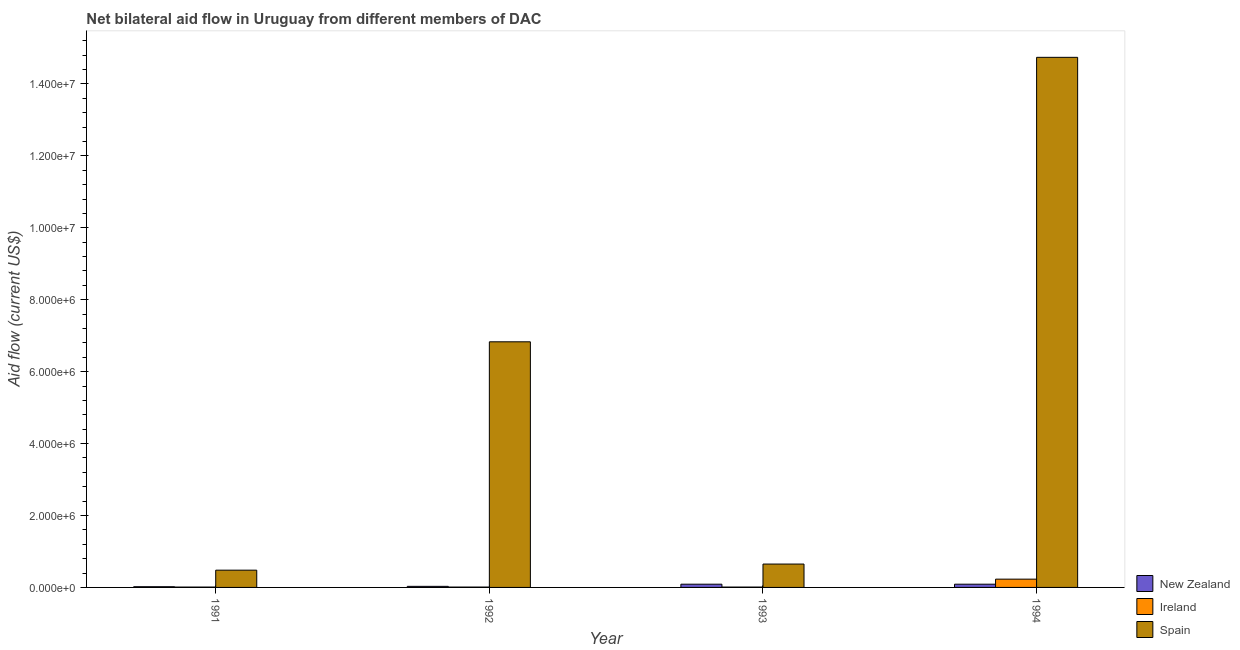How many different coloured bars are there?
Offer a terse response. 3. What is the amount of aid provided by spain in 1993?
Give a very brief answer. 6.50e+05. Across all years, what is the maximum amount of aid provided by new zealand?
Offer a terse response. 9.00e+04. Across all years, what is the minimum amount of aid provided by new zealand?
Provide a short and direct response. 2.00e+04. In which year was the amount of aid provided by spain minimum?
Offer a very short reply. 1991. What is the total amount of aid provided by spain in the graph?
Your response must be concise. 2.27e+07. What is the difference between the amount of aid provided by ireland in 1991 and that in 1994?
Your answer should be very brief. -2.20e+05. What is the difference between the amount of aid provided by new zealand in 1992 and the amount of aid provided by spain in 1994?
Your answer should be compact. -6.00e+04. What is the average amount of aid provided by new zealand per year?
Offer a very short reply. 5.75e+04. In the year 1992, what is the difference between the amount of aid provided by ireland and amount of aid provided by new zealand?
Offer a very short reply. 0. In how many years, is the amount of aid provided by ireland greater than 1600000 US$?
Your response must be concise. 0. What is the ratio of the amount of aid provided by ireland in 1993 to that in 1994?
Provide a short and direct response. 0.04. Is the amount of aid provided by spain in 1992 less than that in 1994?
Provide a succinct answer. Yes. Is the difference between the amount of aid provided by new zealand in 1993 and 1994 greater than the difference between the amount of aid provided by spain in 1993 and 1994?
Offer a very short reply. No. What is the difference between the highest and the second highest amount of aid provided by new zealand?
Ensure brevity in your answer.  0. What is the difference between the highest and the lowest amount of aid provided by ireland?
Keep it short and to the point. 2.20e+05. What does the 3rd bar from the right in 1994 represents?
Keep it short and to the point. New Zealand. Is it the case that in every year, the sum of the amount of aid provided by new zealand and amount of aid provided by ireland is greater than the amount of aid provided by spain?
Keep it short and to the point. No. Does the graph contain any zero values?
Keep it short and to the point. No. Does the graph contain grids?
Offer a very short reply. No. Where does the legend appear in the graph?
Offer a very short reply. Bottom right. How many legend labels are there?
Offer a terse response. 3. How are the legend labels stacked?
Your answer should be very brief. Vertical. What is the title of the graph?
Provide a short and direct response. Net bilateral aid flow in Uruguay from different members of DAC. Does "Labor Tax" appear as one of the legend labels in the graph?
Your response must be concise. No. What is the label or title of the Y-axis?
Your answer should be compact. Aid flow (current US$). What is the Aid flow (current US$) of Spain in 1991?
Your answer should be very brief. 4.80e+05. What is the Aid flow (current US$) in Spain in 1992?
Your response must be concise. 6.83e+06. What is the Aid flow (current US$) in New Zealand in 1993?
Make the answer very short. 9.00e+04. What is the Aid flow (current US$) in Ireland in 1993?
Keep it short and to the point. 10000. What is the Aid flow (current US$) of Spain in 1993?
Offer a very short reply. 6.50e+05. What is the Aid flow (current US$) in Ireland in 1994?
Offer a very short reply. 2.30e+05. What is the Aid flow (current US$) in Spain in 1994?
Your answer should be compact. 1.47e+07. Across all years, what is the maximum Aid flow (current US$) of Ireland?
Make the answer very short. 2.30e+05. Across all years, what is the maximum Aid flow (current US$) of Spain?
Offer a very short reply. 1.47e+07. Across all years, what is the minimum Aid flow (current US$) of Spain?
Offer a terse response. 4.80e+05. What is the total Aid flow (current US$) in Spain in the graph?
Your answer should be compact. 2.27e+07. What is the difference between the Aid flow (current US$) of Spain in 1991 and that in 1992?
Make the answer very short. -6.35e+06. What is the difference between the Aid flow (current US$) of New Zealand in 1991 and that in 1993?
Ensure brevity in your answer.  -7.00e+04. What is the difference between the Aid flow (current US$) in Spain in 1991 and that in 1994?
Your answer should be compact. -1.43e+07. What is the difference between the Aid flow (current US$) in New Zealand in 1992 and that in 1993?
Your answer should be compact. -6.00e+04. What is the difference between the Aid flow (current US$) of Ireland in 1992 and that in 1993?
Ensure brevity in your answer.  0. What is the difference between the Aid flow (current US$) in Spain in 1992 and that in 1993?
Ensure brevity in your answer.  6.18e+06. What is the difference between the Aid flow (current US$) of New Zealand in 1992 and that in 1994?
Ensure brevity in your answer.  -6.00e+04. What is the difference between the Aid flow (current US$) of Spain in 1992 and that in 1994?
Your answer should be compact. -7.91e+06. What is the difference between the Aid flow (current US$) in Spain in 1993 and that in 1994?
Make the answer very short. -1.41e+07. What is the difference between the Aid flow (current US$) in New Zealand in 1991 and the Aid flow (current US$) in Ireland in 1992?
Your answer should be very brief. 10000. What is the difference between the Aid flow (current US$) of New Zealand in 1991 and the Aid flow (current US$) of Spain in 1992?
Your response must be concise. -6.81e+06. What is the difference between the Aid flow (current US$) in Ireland in 1991 and the Aid flow (current US$) in Spain in 1992?
Keep it short and to the point. -6.82e+06. What is the difference between the Aid flow (current US$) of New Zealand in 1991 and the Aid flow (current US$) of Spain in 1993?
Your response must be concise. -6.30e+05. What is the difference between the Aid flow (current US$) in Ireland in 1991 and the Aid flow (current US$) in Spain in 1993?
Your answer should be compact. -6.40e+05. What is the difference between the Aid flow (current US$) of New Zealand in 1991 and the Aid flow (current US$) of Spain in 1994?
Offer a terse response. -1.47e+07. What is the difference between the Aid flow (current US$) of Ireland in 1991 and the Aid flow (current US$) of Spain in 1994?
Give a very brief answer. -1.47e+07. What is the difference between the Aid flow (current US$) in New Zealand in 1992 and the Aid flow (current US$) in Spain in 1993?
Your answer should be compact. -6.20e+05. What is the difference between the Aid flow (current US$) of Ireland in 1992 and the Aid flow (current US$) of Spain in 1993?
Your answer should be very brief. -6.40e+05. What is the difference between the Aid flow (current US$) of New Zealand in 1992 and the Aid flow (current US$) of Ireland in 1994?
Ensure brevity in your answer.  -2.00e+05. What is the difference between the Aid flow (current US$) in New Zealand in 1992 and the Aid flow (current US$) in Spain in 1994?
Your answer should be very brief. -1.47e+07. What is the difference between the Aid flow (current US$) of Ireland in 1992 and the Aid flow (current US$) of Spain in 1994?
Make the answer very short. -1.47e+07. What is the difference between the Aid flow (current US$) in New Zealand in 1993 and the Aid flow (current US$) in Ireland in 1994?
Give a very brief answer. -1.40e+05. What is the difference between the Aid flow (current US$) in New Zealand in 1993 and the Aid flow (current US$) in Spain in 1994?
Your answer should be compact. -1.46e+07. What is the difference between the Aid flow (current US$) in Ireland in 1993 and the Aid flow (current US$) in Spain in 1994?
Offer a terse response. -1.47e+07. What is the average Aid flow (current US$) in New Zealand per year?
Provide a succinct answer. 5.75e+04. What is the average Aid flow (current US$) of Ireland per year?
Provide a short and direct response. 6.50e+04. What is the average Aid flow (current US$) in Spain per year?
Make the answer very short. 5.68e+06. In the year 1991, what is the difference between the Aid flow (current US$) of New Zealand and Aid flow (current US$) of Spain?
Keep it short and to the point. -4.60e+05. In the year 1991, what is the difference between the Aid flow (current US$) in Ireland and Aid flow (current US$) in Spain?
Provide a short and direct response. -4.70e+05. In the year 1992, what is the difference between the Aid flow (current US$) in New Zealand and Aid flow (current US$) in Spain?
Your response must be concise. -6.80e+06. In the year 1992, what is the difference between the Aid flow (current US$) of Ireland and Aid flow (current US$) of Spain?
Your response must be concise. -6.82e+06. In the year 1993, what is the difference between the Aid flow (current US$) of New Zealand and Aid flow (current US$) of Ireland?
Offer a terse response. 8.00e+04. In the year 1993, what is the difference between the Aid flow (current US$) of New Zealand and Aid flow (current US$) of Spain?
Your response must be concise. -5.60e+05. In the year 1993, what is the difference between the Aid flow (current US$) in Ireland and Aid flow (current US$) in Spain?
Provide a succinct answer. -6.40e+05. In the year 1994, what is the difference between the Aid flow (current US$) in New Zealand and Aid flow (current US$) in Spain?
Provide a short and direct response. -1.46e+07. In the year 1994, what is the difference between the Aid flow (current US$) in Ireland and Aid flow (current US$) in Spain?
Your answer should be compact. -1.45e+07. What is the ratio of the Aid flow (current US$) in Spain in 1991 to that in 1992?
Ensure brevity in your answer.  0.07. What is the ratio of the Aid flow (current US$) in New Zealand in 1991 to that in 1993?
Make the answer very short. 0.22. What is the ratio of the Aid flow (current US$) of Spain in 1991 to that in 1993?
Your answer should be compact. 0.74. What is the ratio of the Aid flow (current US$) of New Zealand in 1991 to that in 1994?
Offer a terse response. 0.22. What is the ratio of the Aid flow (current US$) in Ireland in 1991 to that in 1994?
Your answer should be compact. 0.04. What is the ratio of the Aid flow (current US$) in Spain in 1991 to that in 1994?
Make the answer very short. 0.03. What is the ratio of the Aid flow (current US$) in Spain in 1992 to that in 1993?
Your response must be concise. 10.51. What is the ratio of the Aid flow (current US$) of Ireland in 1992 to that in 1994?
Provide a succinct answer. 0.04. What is the ratio of the Aid flow (current US$) in Spain in 1992 to that in 1994?
Make the answer very short. 0.46. What is the ratio of the Aid flow (current US$) of Ireland in 1993 to that in 1994?
Your answer should be very brief. 0.04. What is the ratio of the Aid flow (current US$) of Spain in 1993 to that in 1994?
Provide a short and direct response. 0.04. What is the difference between the highest and the second highest Aid flow (current US$) in New Zealand?
Keep it short and to the point. 0. What is the difference between the highest and the second highest Aid flow (current US$) in Spain?
Provide a short and direct response. 7.91e+06. What is the difference between the highest and the lowest Aid flow (current US$) in New Zealand?
Give a very brief answer. 7.00e+04. What is the difference between the highest and the lowest Aid flow (current US$) in Spain?
Ensure brevity in your answer.  1.43e+07. 